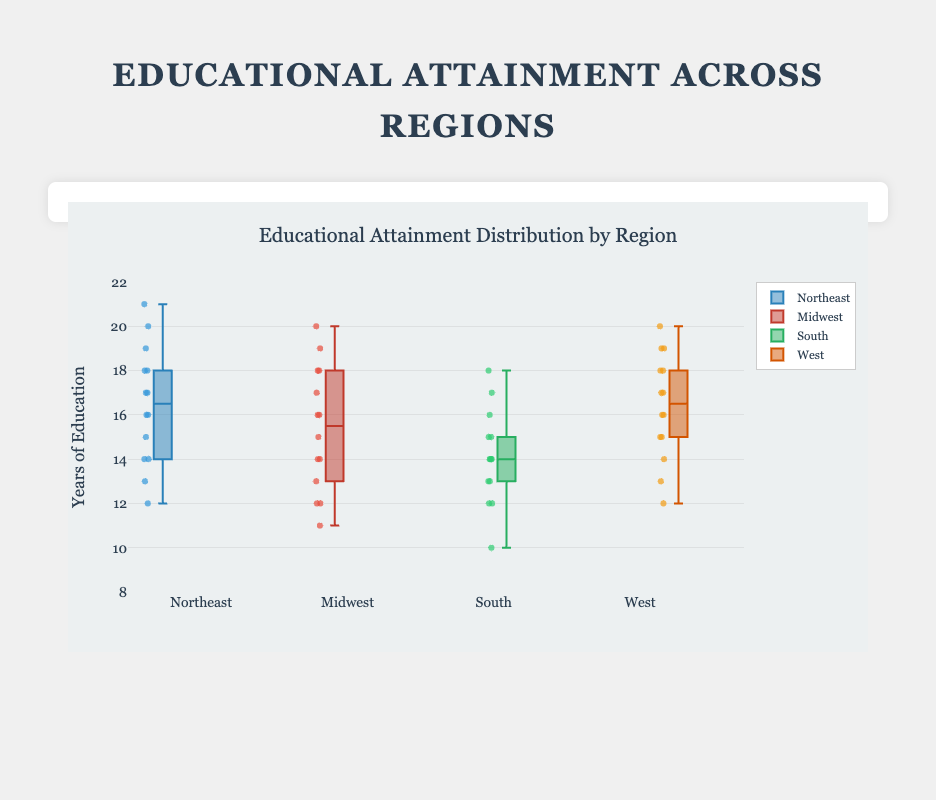What is the title of the box plot? The title is usually found at the top of the figure. In this case, it is "Educational Attainment Distribution by Region".
Answer: Educational Attainment Distribution by Region What is the y-axis title in the box plot? The y-axis title is usually placed vertically along the y-axis, describing what the axis represents. Here, it is "Years of Education".
Answer: Years of Education Which region has the highest median educational attainment? By looking at the central line inside each box, which represents the median, we can see that the Northeast region has the highest median.
Answer: Northeast What is the range of the educational attainment data for the South region? The range of the data can be determined by subtracting the smallest value from the largest value in the South region's data. The smallest value is 10 and the largest value is 18, so the range is 18 - 10 = 8.
Answer: 8 Which region shows the largest interquartile range (IQR) for educational attainment? The IQR is the distance between the first quartile (Q1) and third quartile (Q3). By comparing the box heights, it is clear the Midwest has the largest IQR.
Answer: Midwest What is the interquartile range (IQR) for the Midwest region? The IQR is calculated by subtracting Q1 from Q3. For the Midwest region, Q3 is approximately 18 and Q1 is about 13. So, the IQR is 18 - 13 = 5.
Answer: 5 How many regions have outliers? Outliers are points displayed outside of the whiskers in the box plot. By checking each box plot, we see that only the Northeast and West regions have outliers.
Answer: 2 Which region has the lowest maximum educational attainment? The maximum educational attainment is the highest point within the whiskers for each box plot. Comparing the maximum points, the South region has the lowest maximum at around 18 years.
Answer: South In which region is the median educational attainment closest to the first quartile of the West region? First, identify the first quartile (Q1) of the West region, which is around 15 years. Then, observe which region’s median is closest to this value. The median for the Midwest region is closest to 15.
Answer: Midwest What is the median educational attainment in the South region? The median is represented by the line within the box for each region. For the South region, this line is at approximately 15 years.
Answer: 15 